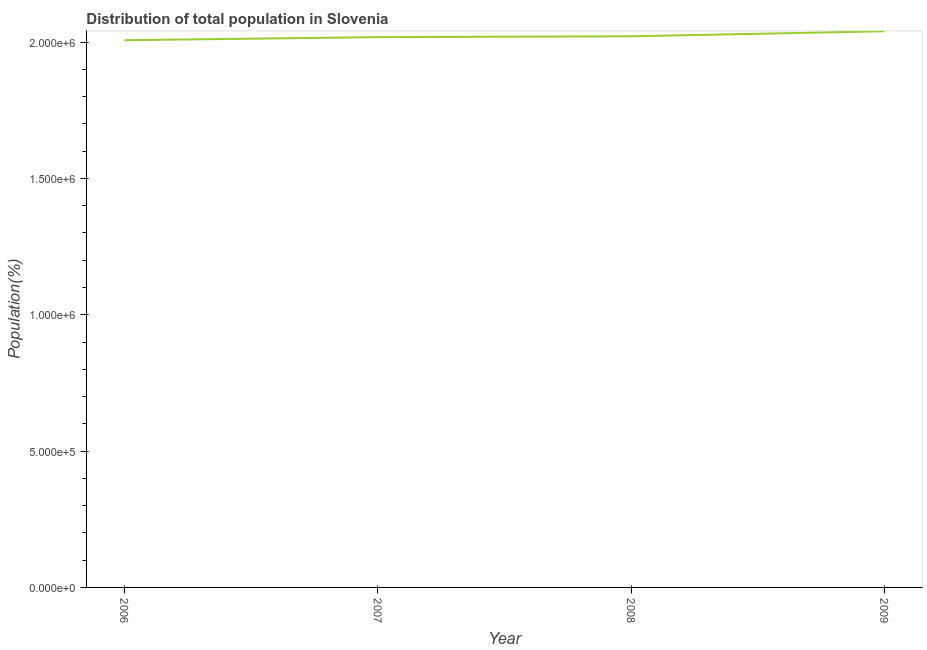What is the population in 2009?
Offer a terse response. 2.04e+06. Across all years, what is the maximum population?
Your answer should be very brief. 2.04e+06. Across all years, what is the minimum population?
Ensure brevity in your answer.  2.01e+06. In which year was the population maximum?
Keep it short and to the point. 2009. What is the sum of the population?
Give a very brief answer. 8.09e+06. What is the difference between the population in 2006 and 2008?
Your answer should be compact. -1.44e+04. What is the average population per year?
Offer a very short reply. 2.02e+06. What is the median population?
Your answer should be compact. 2.02e+06. What is the ratio of the population in 2006 to that in 2008?
Offer a very short reply. 0.99. Is the population in 2006 less than that in 2008?
Make the answer very short. Yes. What is the difference between the highest and the second highest population?
Offer a very short reply. 1.84e+04. Is the sum of the population in 2007 and 2008 greater than the maximum population across all years?
Make the answer very short. Yes. What is the difference between the highest and the lowest population?
Ensure brevity in your answer.  3.28e+04. In how many years, is the population greater than the average population taken over all years?
Your answer should be very brief. 1. How many lines are there?
Make the answer very short. 1. How many years are there in the graph?
Your answer should be very brief. 4. What is the difference between two consecutive major ticks on the Y-axis?
Ensure brevity in your answer.  5.00e+05. Does the graph contain any zero values?
Ensure brevity in your answer.  No. Does the graph contain grids?
Provide a succinct answer. No. What is the title of the graph?
Provide a succinct answer. Distribution of total population in Slovenia . What is the label or title of the X-axis?
Keep it short and to the point. Year. What is the label or title of the Y-axis?
Your answer should be very brief. Population(%). What is the Population(%) of 2006?
Ensure brevity in your answer.  2.01e+06. What is the Population(%) in 2007?
Offer a terse response. 2.02e+06. What is the Population(%) in 2008?
Provide a short and direct response. 2.02e+06. What is the Population(%) of 2009?
Your response must be concise. 2.04e+06. What is the difference between the Population(%) in 2006 and 2007?
Your answer should be compact. -1.13e+04. What is the difference between the Population(%) in 2006 and 2008?
Make the answer very short. -1.44e+04. What is the difference between the Population(%) in 2006 and 2009?
Your answer should be compact. -3.28e+04. What is the difference between the Population(%) in 2007 and 2008?
Your response must be concise. -3194. What is the difference between the Population(%) in 2007 and 2009?
Provide a short and direct response. -2.15e+04. What is the difference between the Population(%) in 2008 and 2009?
Make the answer very short. -1.84e+04. What is the ratio of the Population(%) in 2006 to that in 2007?
Give a very brief answer. 0.99. 